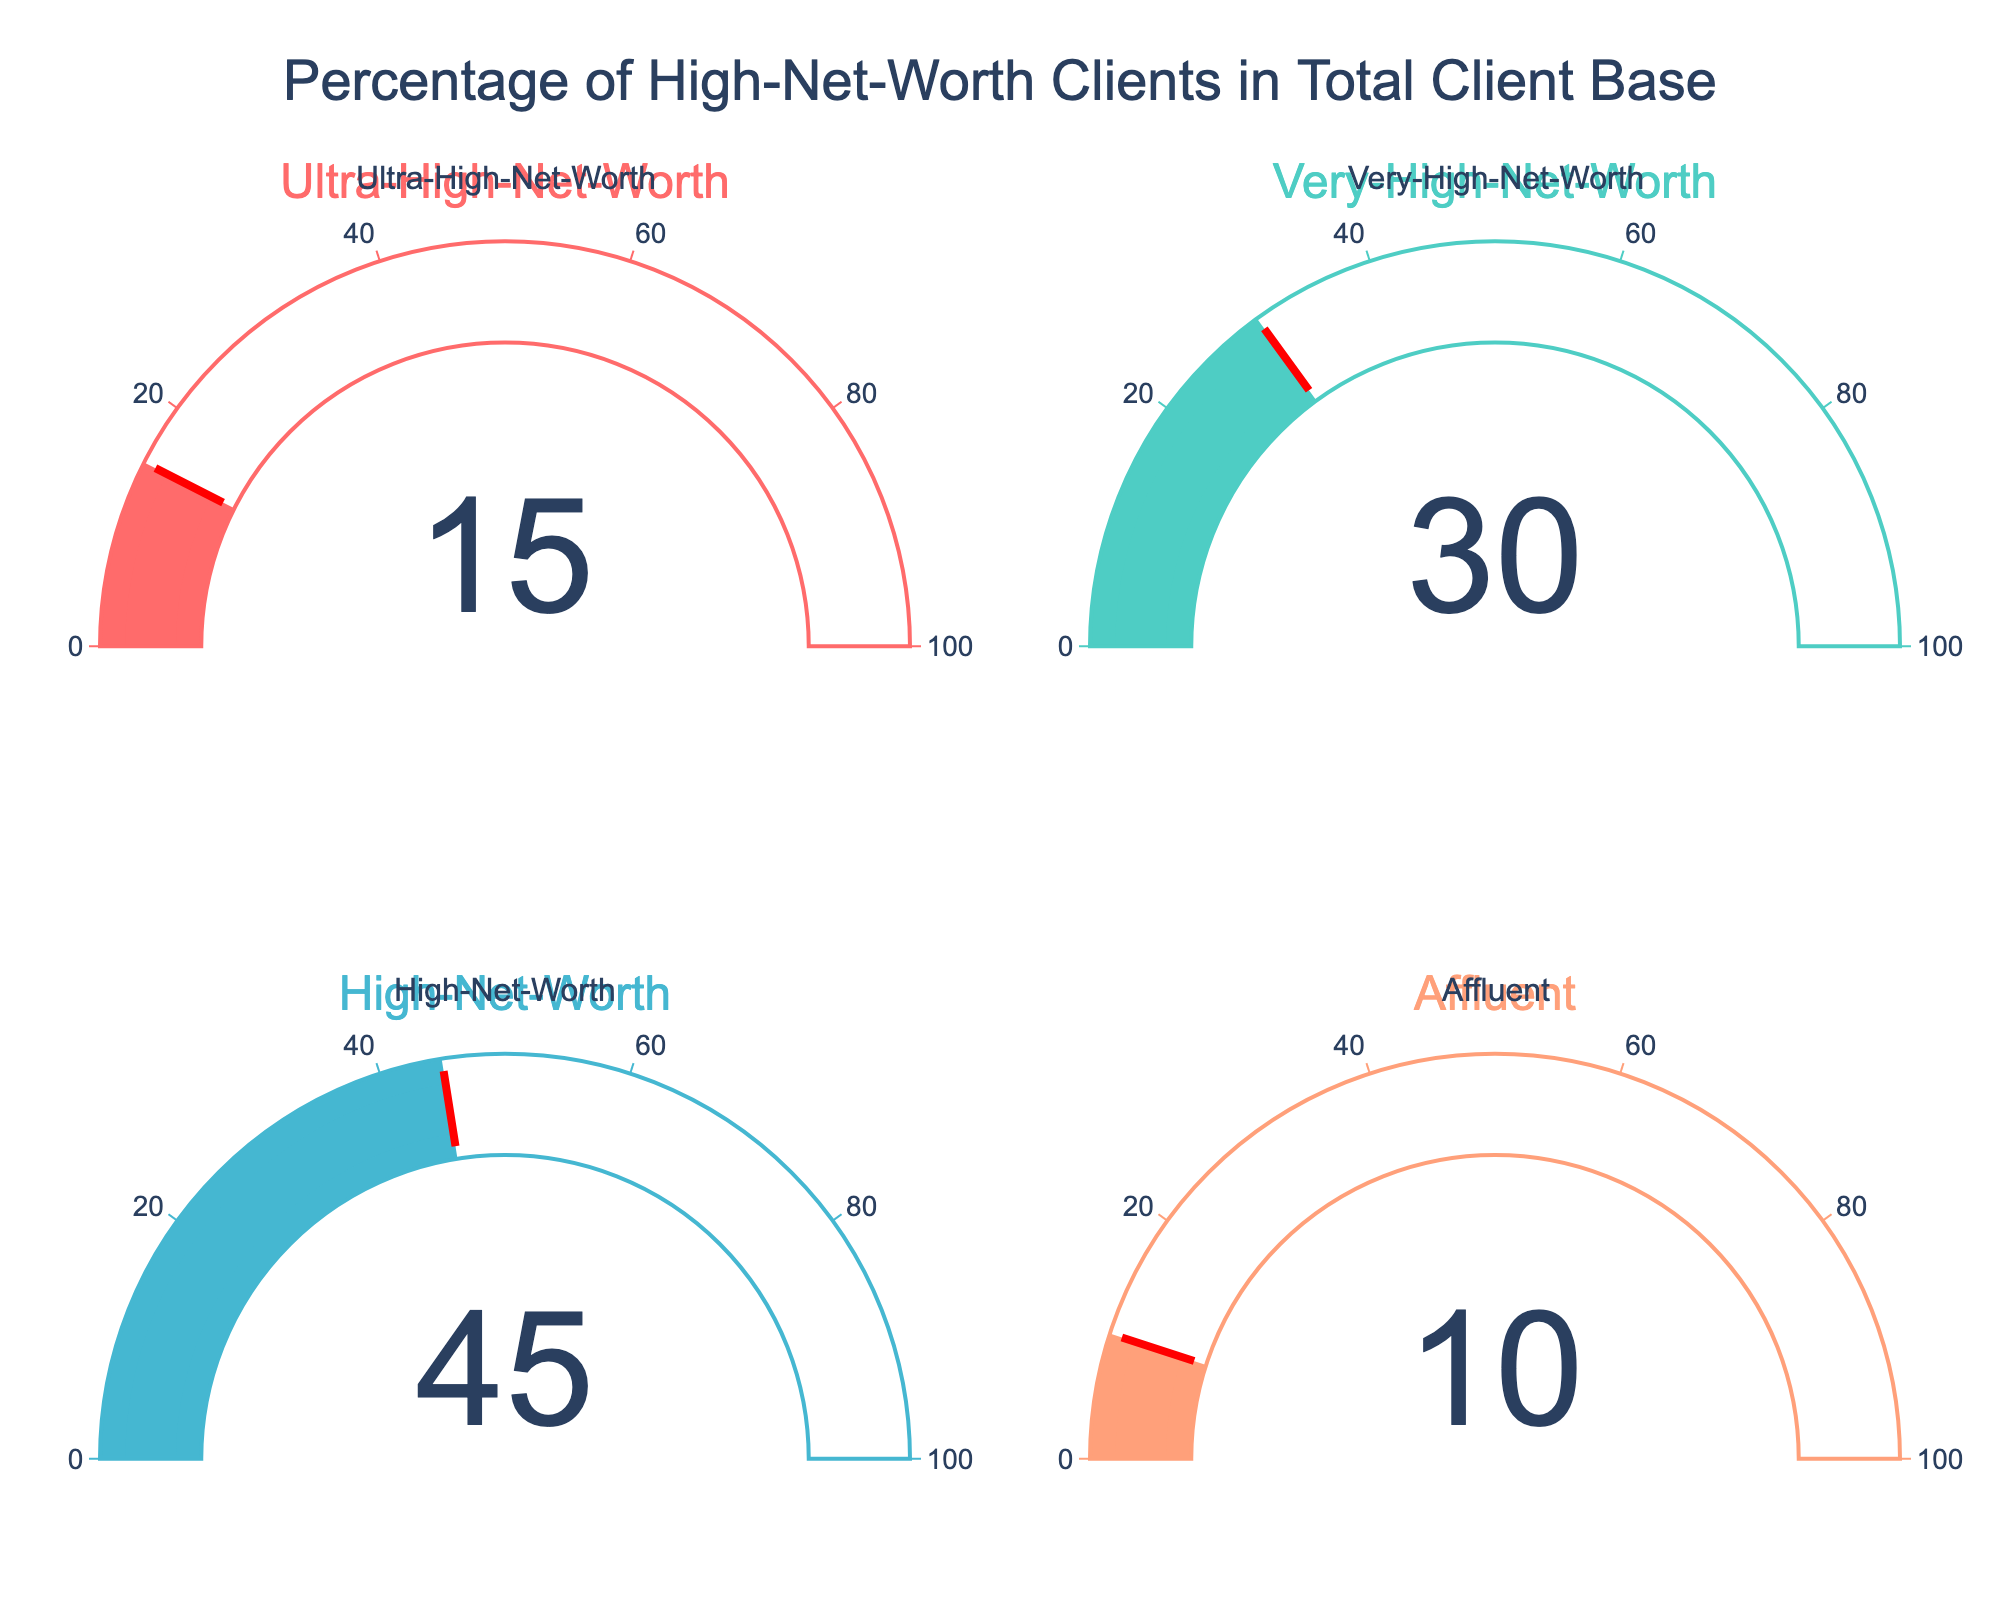What is the title of the plot? The title is centered at the top of the figure and reads "Percentage of High-Net-Worth Clients in Total Client Base".
Answer: Percentage of High-Net-Worth Clients in Total Client Base Which client segment has the highest percentage? From the figure, the "High-Net-Worth" gauge shows the highest value, which is greater than all other segments.
Answer: High-Net-Worth What is the percentage of Ultra-High-Net-Worth clients? The gauge for the "Ultra-High-Net-Worth" segment shows the number 15, indicating 15%.
Answer: 15% How many client segments are shown in the figure? The figure is divided into four equal parts with four different gauges, each representing a client segment.
Answer: 4 Compare the percentage of Very-High-Net-Worth clients to Affluent clients. The "Very-High-Net-Worth" segment shows 30%, while the "Affluent" segment shows 10%. Comparing the two, 30% is greater than 10%.
Answer: Very-High-Net-Worth has more What is the combined percentage of Ultra-High-Net-Worth and Affluent clients? The Ultra-High-Net-Worth clients have 15%, and Affluent clients have 10%. Combined, this results in 15% + 10% = 25%.
Answer: 25% Which client segment has the threshold marker? The threshold marker, as indicated by a red line, is present on the gauges. Each segment has a threshold equal to its value: Ultra-High-Net-Worth (15), Very-High-Net-Worth (30), High-Net-Worth (45), Affluent (10).
Answer: All segments have a threshold marker Is the percentage of High-Net-Worth clients more than double that of Ultra-High-Net-Worth clients? The High-Net-Worth segment shows 45%, and Ultra-High-Net-Worth shows 15%. 45% is indeed more than double 15% (i.e., 30%).
Answer: Yes What color represents the High-Net-Worth segment? The gauge for the High-Net-Worth segment is colored in a distinct teal/blue shade.
Answer: Teal/Blue 